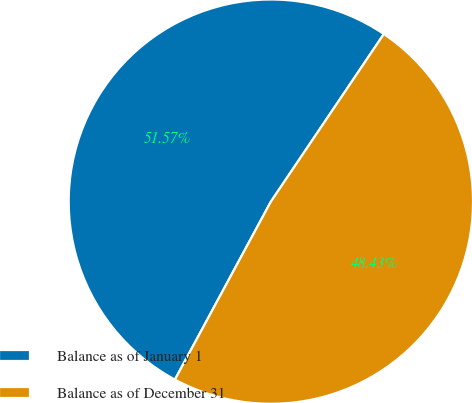Convert chart. <chart><loc_0><loc_0><loc_500><loc_500><pie_chart><fcel>Balance as of January 1<fcel>Balance as of December 31<nl><fcel>51.57%<fcel>48.43%<nl></chart> 